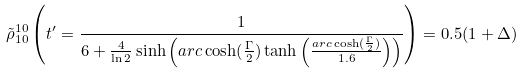Convert formula to latex. <formula><loc_0><loc_0><loc_500><loc_500>\tilde { \rho } _ { 1 0 } ^ { 1 0 } \left ( t ^ { \prime } = \frac { 1 } { 6 + \frac { 4 } { \ln 2 } \sinh \left ( a r c \cosh ( \frac { \Gamma } { 2 } ) \tanh \left ( \frac { a r c \cosh ( \frac { \Gamma } { 2 } ) } { 1 . 6 } \right ) \right ) } \right ) = 0 . 5 ( 1 + \Delta )</formula> 